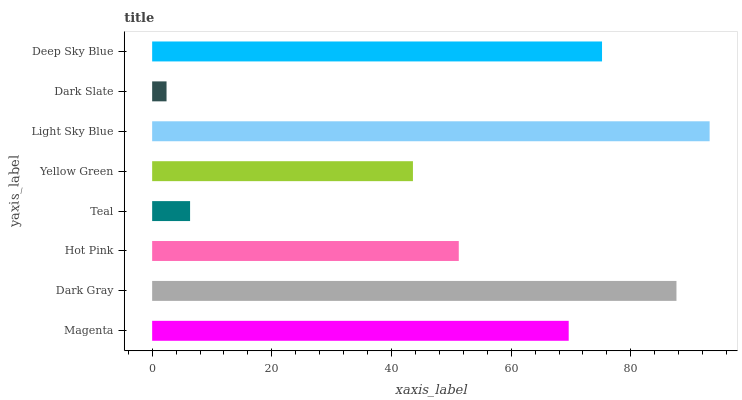Is Dark Slate the minimum?
Answer yes or no. Yes. Is Light Sky Blue the maximum?
Answer yes or no. Yes. Is Dark Gray the minimum?
Answer yes or no. No. Is Dark Gray the maximum?
Answer yes or no. No. Is Dark Gray greater than Magenta?
Answer yes or no. Yes. Is Magenta less than Dark Gray?
Answer yes or no. Yes. Is Magenta greater than Dark Gray?
Answer yes or no. No. Is Dark Gray less than Magenta?
Answer yes or no. No. Is Magenta the high median?
Answer yes or no. Yes. Is Hot Pink the low median?
Answer yes or no. Yes. Is Hot Pink the high median?
Answer yes or no. No. Is Magenta the low median?
Answer yes or no. No. 